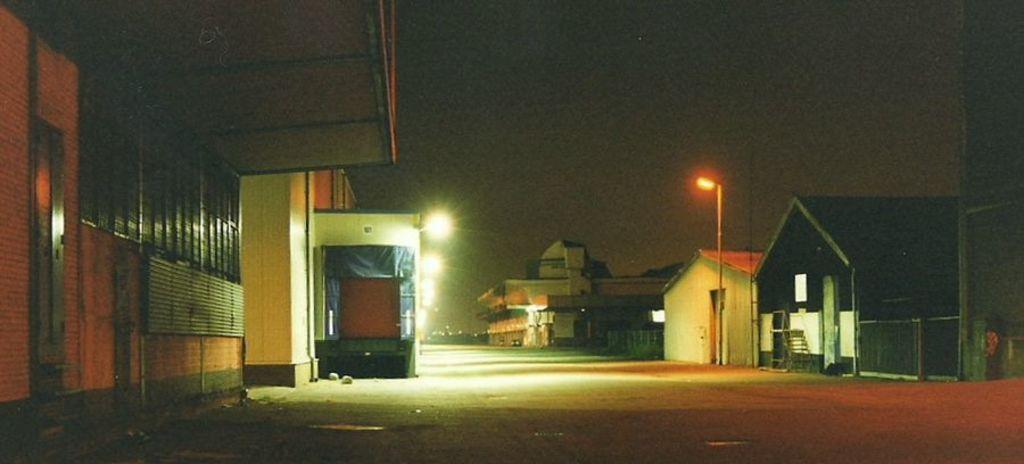Describe this image in one or two sentences. In this image I can see the view of a night on the right side, I can see some house and a pole. 